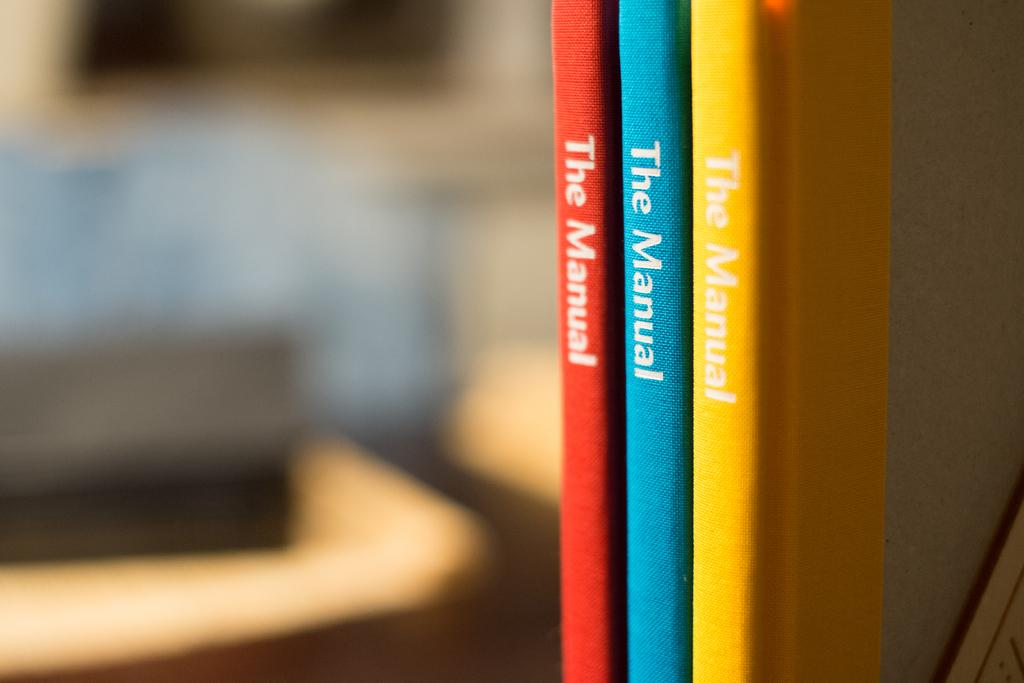<image>
Relay a brief, clear account of the picture shown. A shelf with a red, blue, and yellow books called The Manual. 